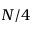<formula> <loc_0><loc_0><loc_500><loc_500>N / 4</formula> 